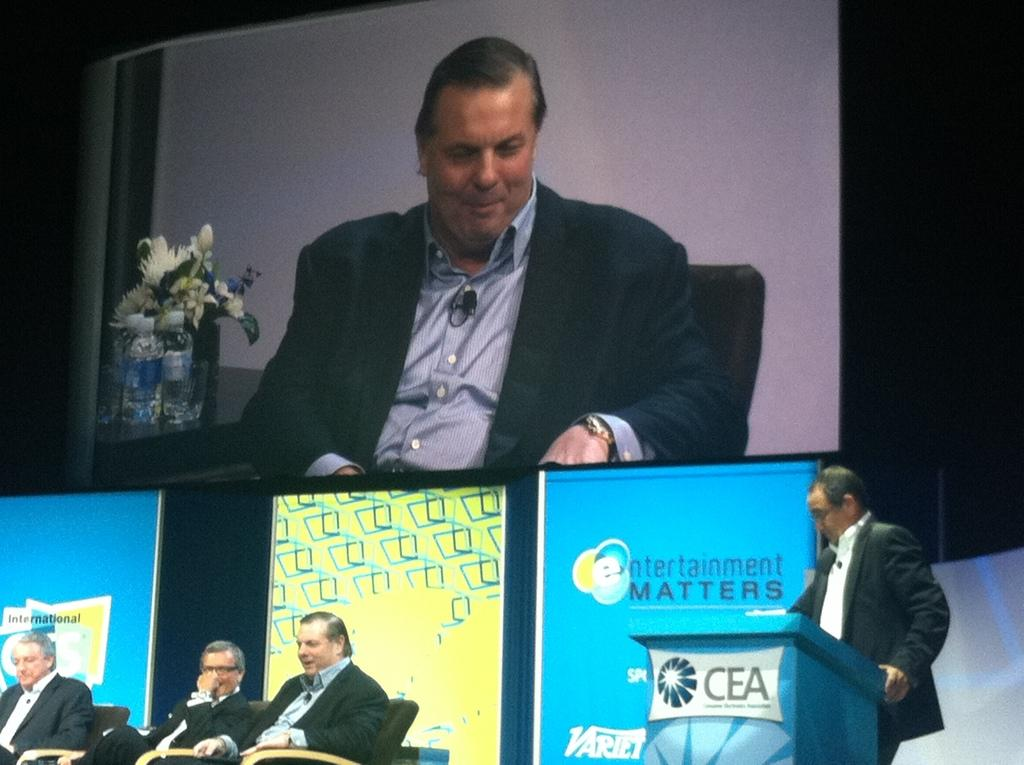What is the main subject of the image? There is a person standing in front of a podium in the image. Where is the person located in relation to the podium? The person is on the right side of the image. What can be seen on the left side of the image? There are three people sitting on chairs on the left side of the image. What are the three people doing? The three people are looking at someone or something. How many hands does the representative have in the image? There is no representative present in the image, and therefore no hands can be counted. 